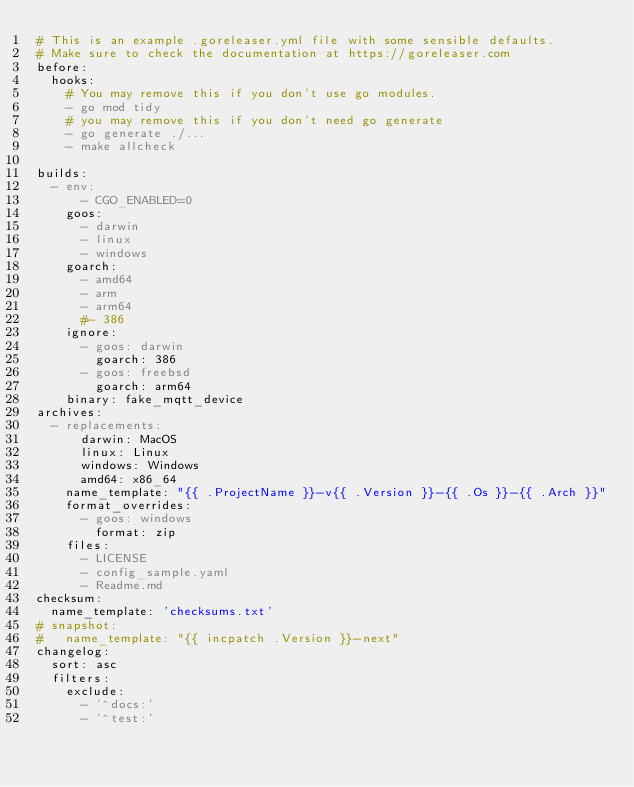<code> <loc_0><loc_0><loc_500><loc_500><_YAML_># This is an example .goreleaser.yml file with some sensible defaults.
# Make sure to check the documentation at https://goreleaser.com
before:
  hooks:
    # You may remove this if you don't use go modules.
    - go mod tidy
    # you may remove this if you don't need go generate
    - go generate ./...
    - make allcheck

builds:
  - env:
      - CGO_ENABLED=0
    goos:
      - darwin
      - linux
      - windows
    goarch:
      - amd64
      - arm
      - arm64
      #- 386
    ignore:
      - goos: darwin
        goarch: 386
      - goos: freebsd
        goarch: arm64
    binary: fake_mqtt_device
archives:
  - replacements:
      darwin: MacOS
      linux: Linux
      windows: Windows
      amd64: x86_64
    name_template: "{{ .ProjectName }}-v{{ .Version }}-{{ .Os }}-{{ .Arch }}"
    format_overrides:
      - goos: windows
        format: zip
    files:
      - LICENSE
      - config_sample.yaml
      - Readme.md
checksum:
  name_template: 'checksums.txt'
# snapshot:
#   name_template: "{{ incpatch .Version }}-next"
changelog:
  sort: asc
  filters:
    exclude:
      - '^docs:'
      - '^test:'
</code> 